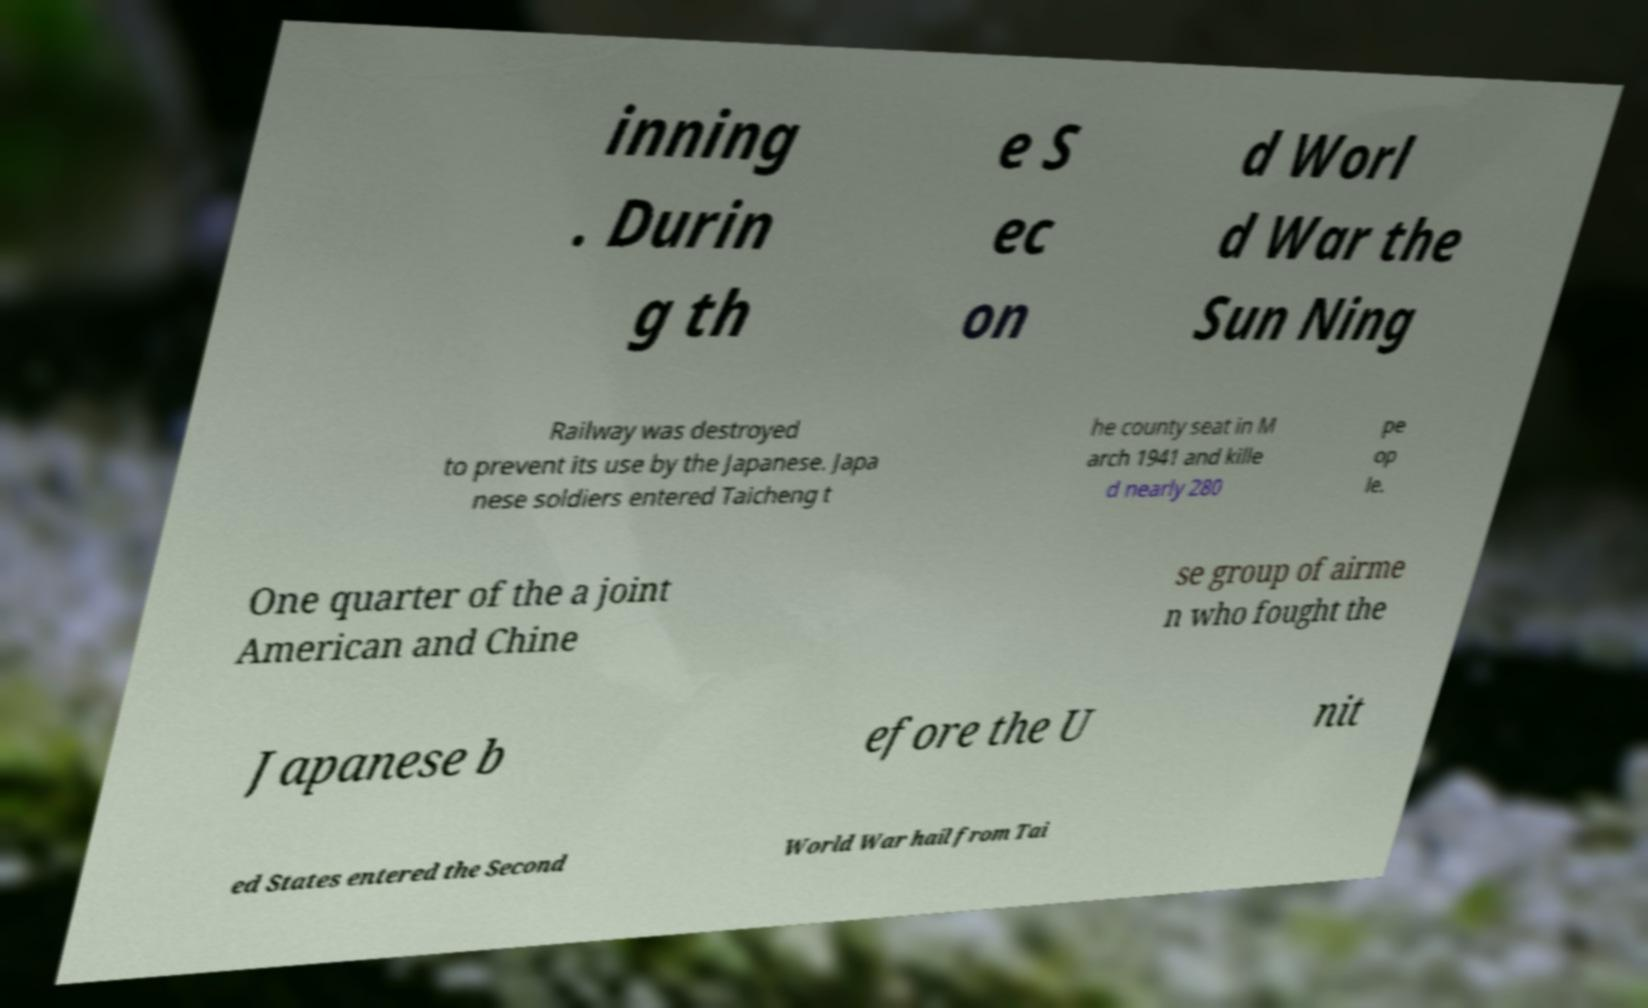Please read and relay the text visible in this image. What does it say? inning . Durin g th e S ec on d Worl d War the Sun Ning Railway was destroyed to prevent its use by the Japanese. Japa nese soldiers entered Taicheng t he county seat in M arch 1941 and kille d nearly 280 pe op le. One quarter of the a joint American and Chine se group of airme n who fought the Japanese b efore the U nit ed States entered the Second World War hail from Tai 